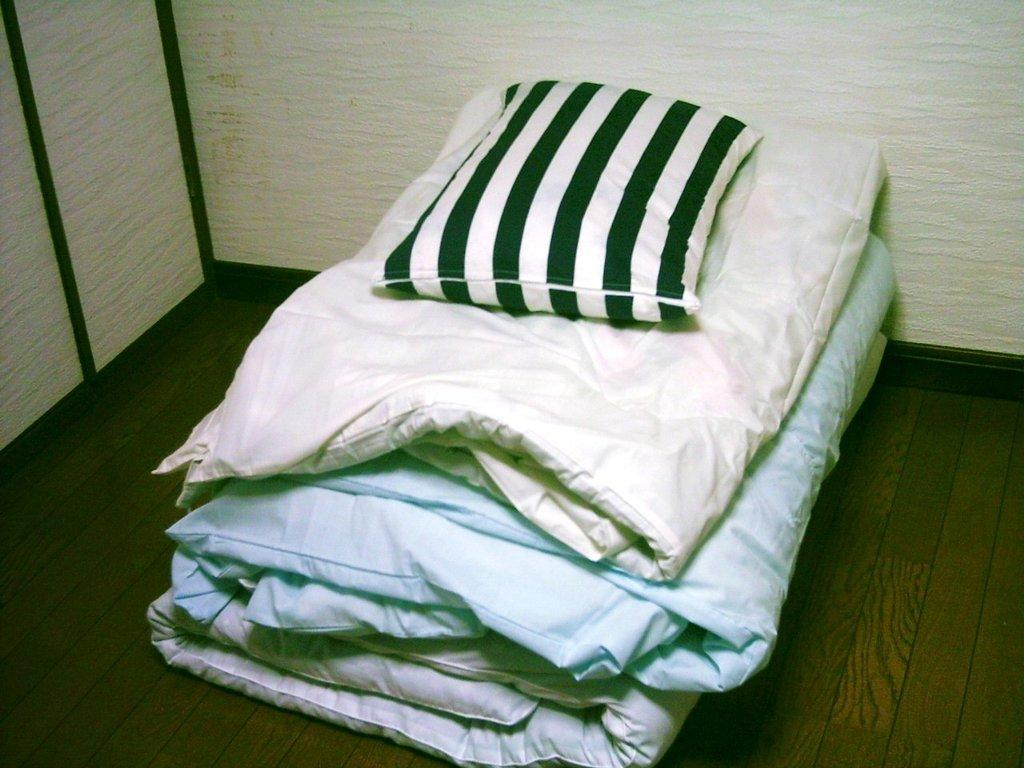What is placed on the wooden surface in the image? There is a pillow and blankets on the wooden surface in the image. What is the color and design of the pillow? The pillow has black and white color design lines on it. What can be seen in the background of the image? The background of the image includes white walls. Is there a cave visible in the image? No, there is no cave present in the image. Can you see a net being used in the image? No, there is no net visible in the image. 